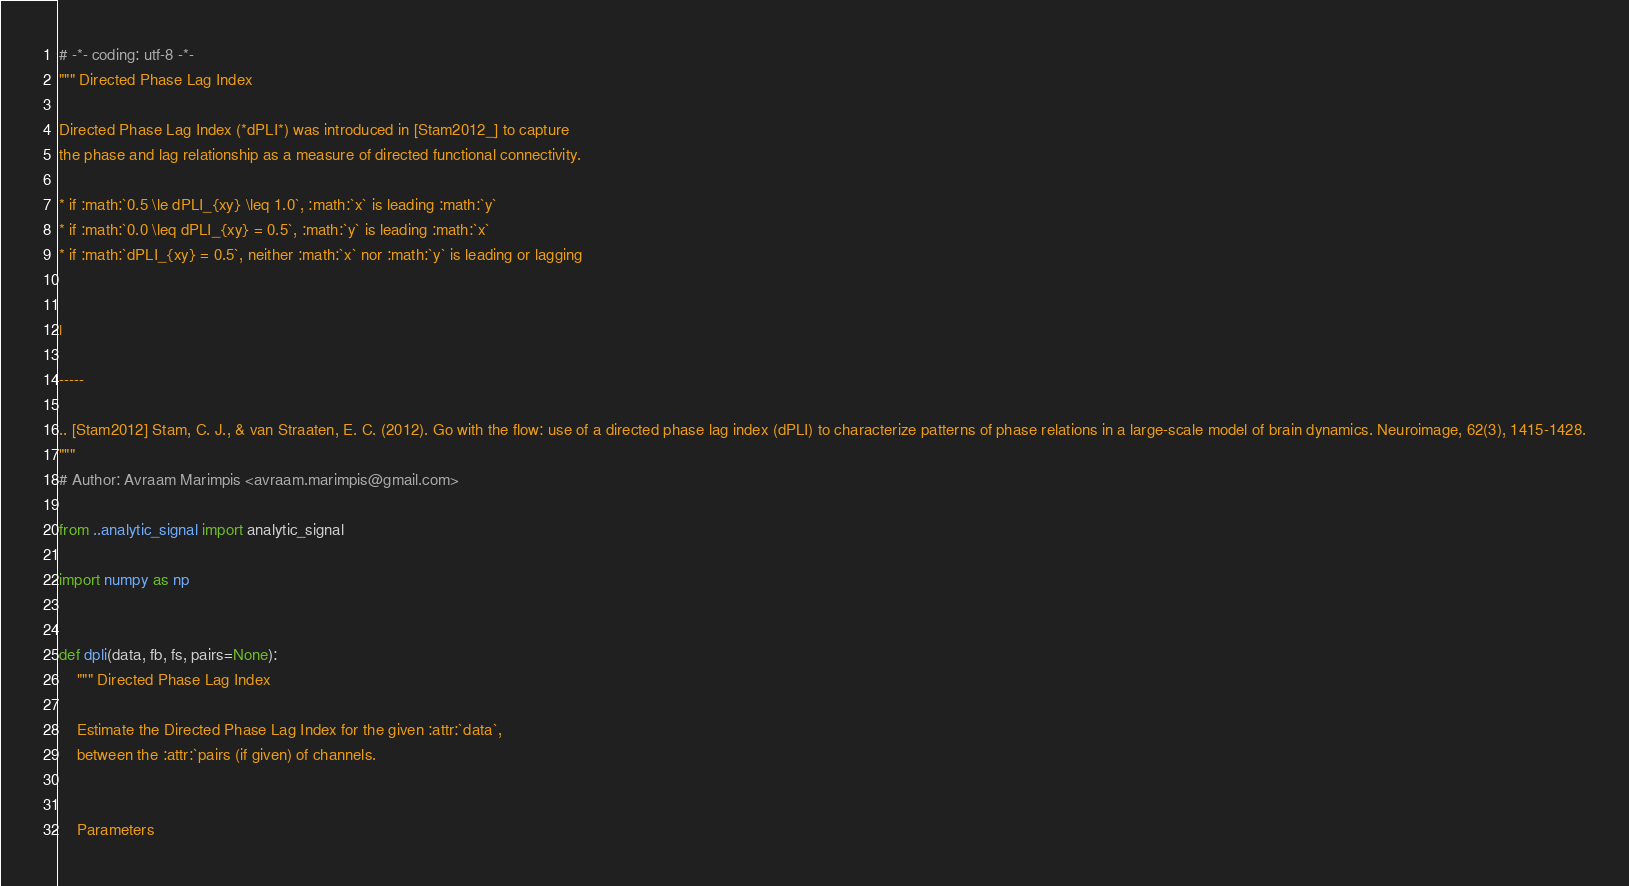Convert code to text. <code><loc_0><loc_0><loc_500><loc_500><_Python_># -*- coding: utf-8 -*-
""" Directed Phase Lag Index

Directed Phase Lag Index (*dPLI*) was introduced in [Stam2012_] to capture
the phase and lag relationship as a measure of directed functional connectivity.

* if :math:`0.5 \le dPLI_{xy} \leq 1.0`, :math:`x` is leading :math:`y`
* if :math:`0.0 \leq dPLI_{xy} = 0.5`, :math:`y` is leading :math:`x`
* if :math:`dPLI_{xy} = 0.5`, neither :math:`x` nor :math:`y` is leading or lagging


|

-----

.. [Stam2012] Stam, C. J., & van Straaten, E. C. (2012). Go with the flow: use of a directed phase lag index (dPLI) to characterize patterns of phase relations in a large-scale model of brain dynamics. Neuroimage, 62(3), 1415-1428.
"""
# Author: Avraam Marimpis <avraam.marimpis@gmail.com>

from ..analytic_signal import analytic_signal

import numpy as np


def dpli(data, fb, fs, pairs=None):
    """ Directed Phase Lag Index

    Estimate the Directed Phase Lag Index for the given :attr:`data`,
    between the :attr:`pairs (if given) of channels.


    Parameters</code> 